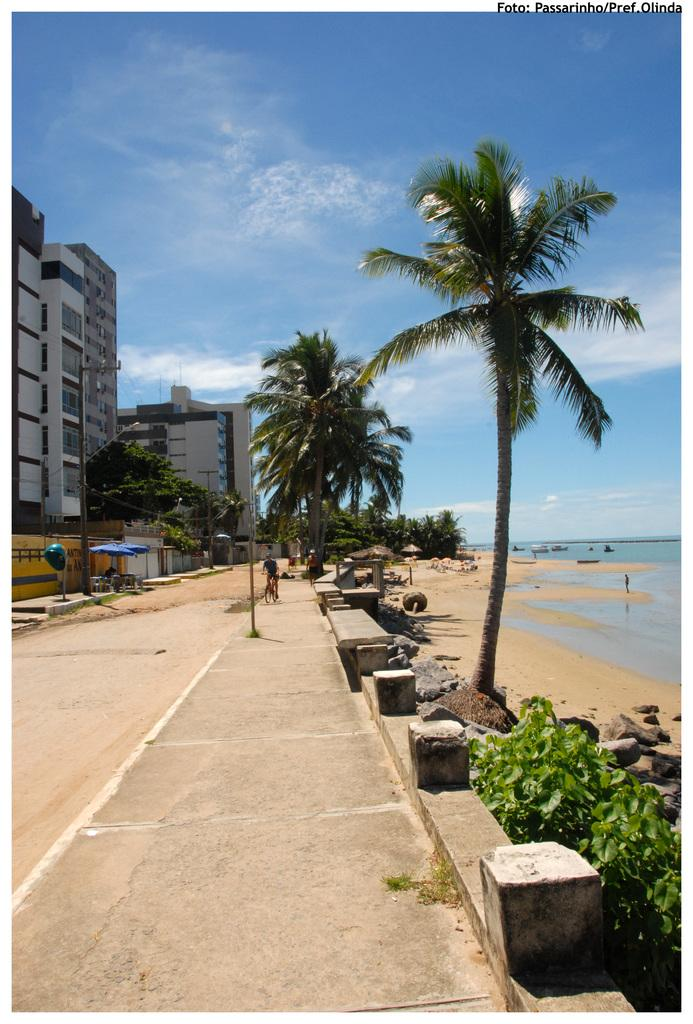What type of structures can be seen in the image? There are buildings in the image. What natural elements are present in the image? There are trees in the image. What utility pole can be seen in the image? There is a current pole in the image. What body of water is visible in the image? There is water visible in the image. What mode of transportation is being used by a person in the image? A man is riding a bicycle in the image. What is visible at the top of the image? The sky is visible at the top of the image. Where is the sofa located in the image? There is no sofa present in the image. What type of growth is visible on the trees in the image? The provided facts do not mention any specific growth on the trees, so we cannot answer this question definitively. 